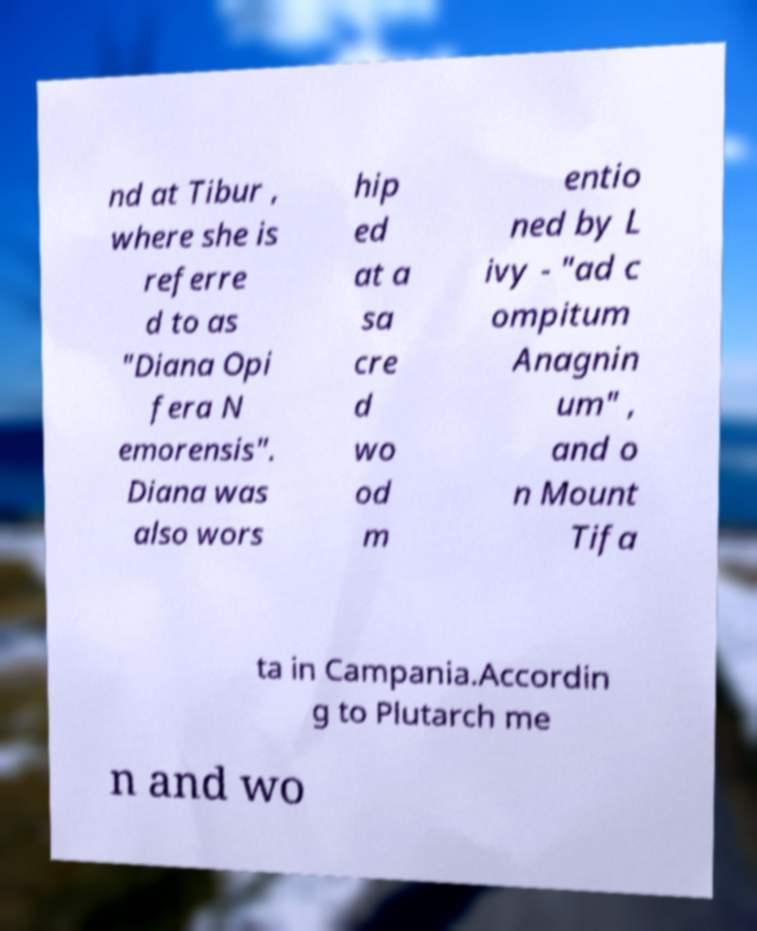For documentation purposes, I need the text within this image transcribed. Could you provide that? nd at Tibur , where she is referre d to as "Diana Opi fera N emorensis". Diana was also wors hip ed at a sa cre d wo od m entio ned by L ivy - "ad c ompitum Anagnin um" , and o n Mount Tifa ta in Campania.Accordin g to Plutarch me n and wo 